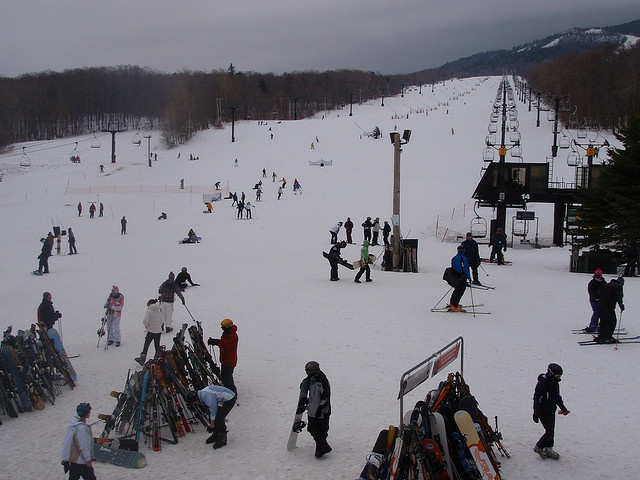Describe the objects in this image and their specific colors. I can see people in gray, darkgray, black, and lightgray tones, snowboard in gray, black, darkgray, and maroon tones, people in gray, black, and darkgray tones, people in gray, black, darkgray, and maroon tones, and people in gray and black tones in this image. 